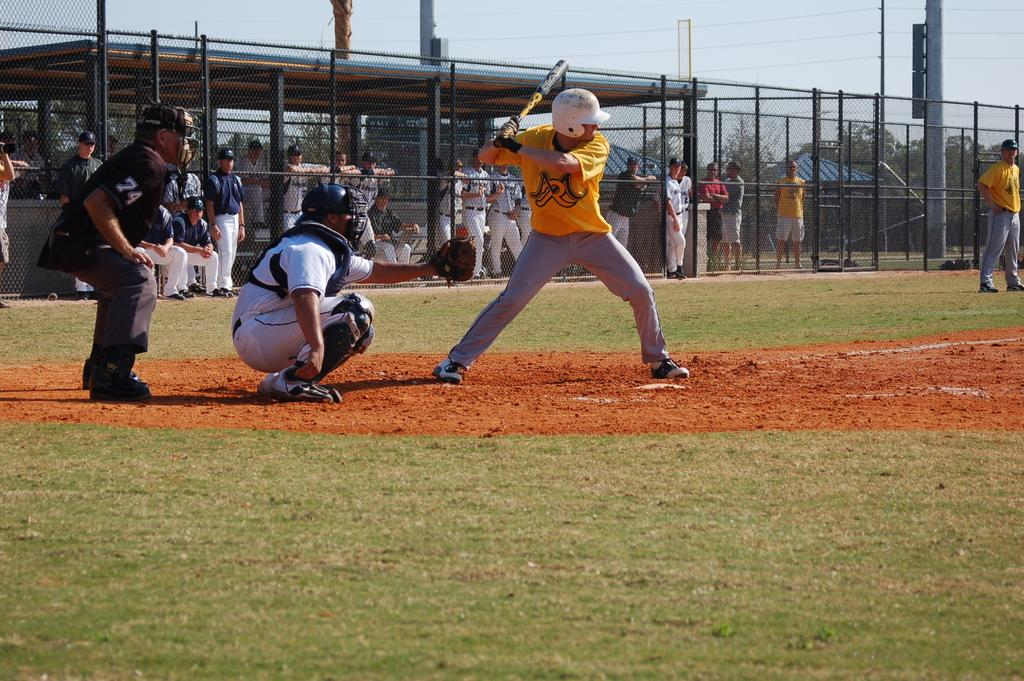<image>
Provide a brief description of the given image. A baseball batter is wearing a yellow shirt with the letter R on it. 